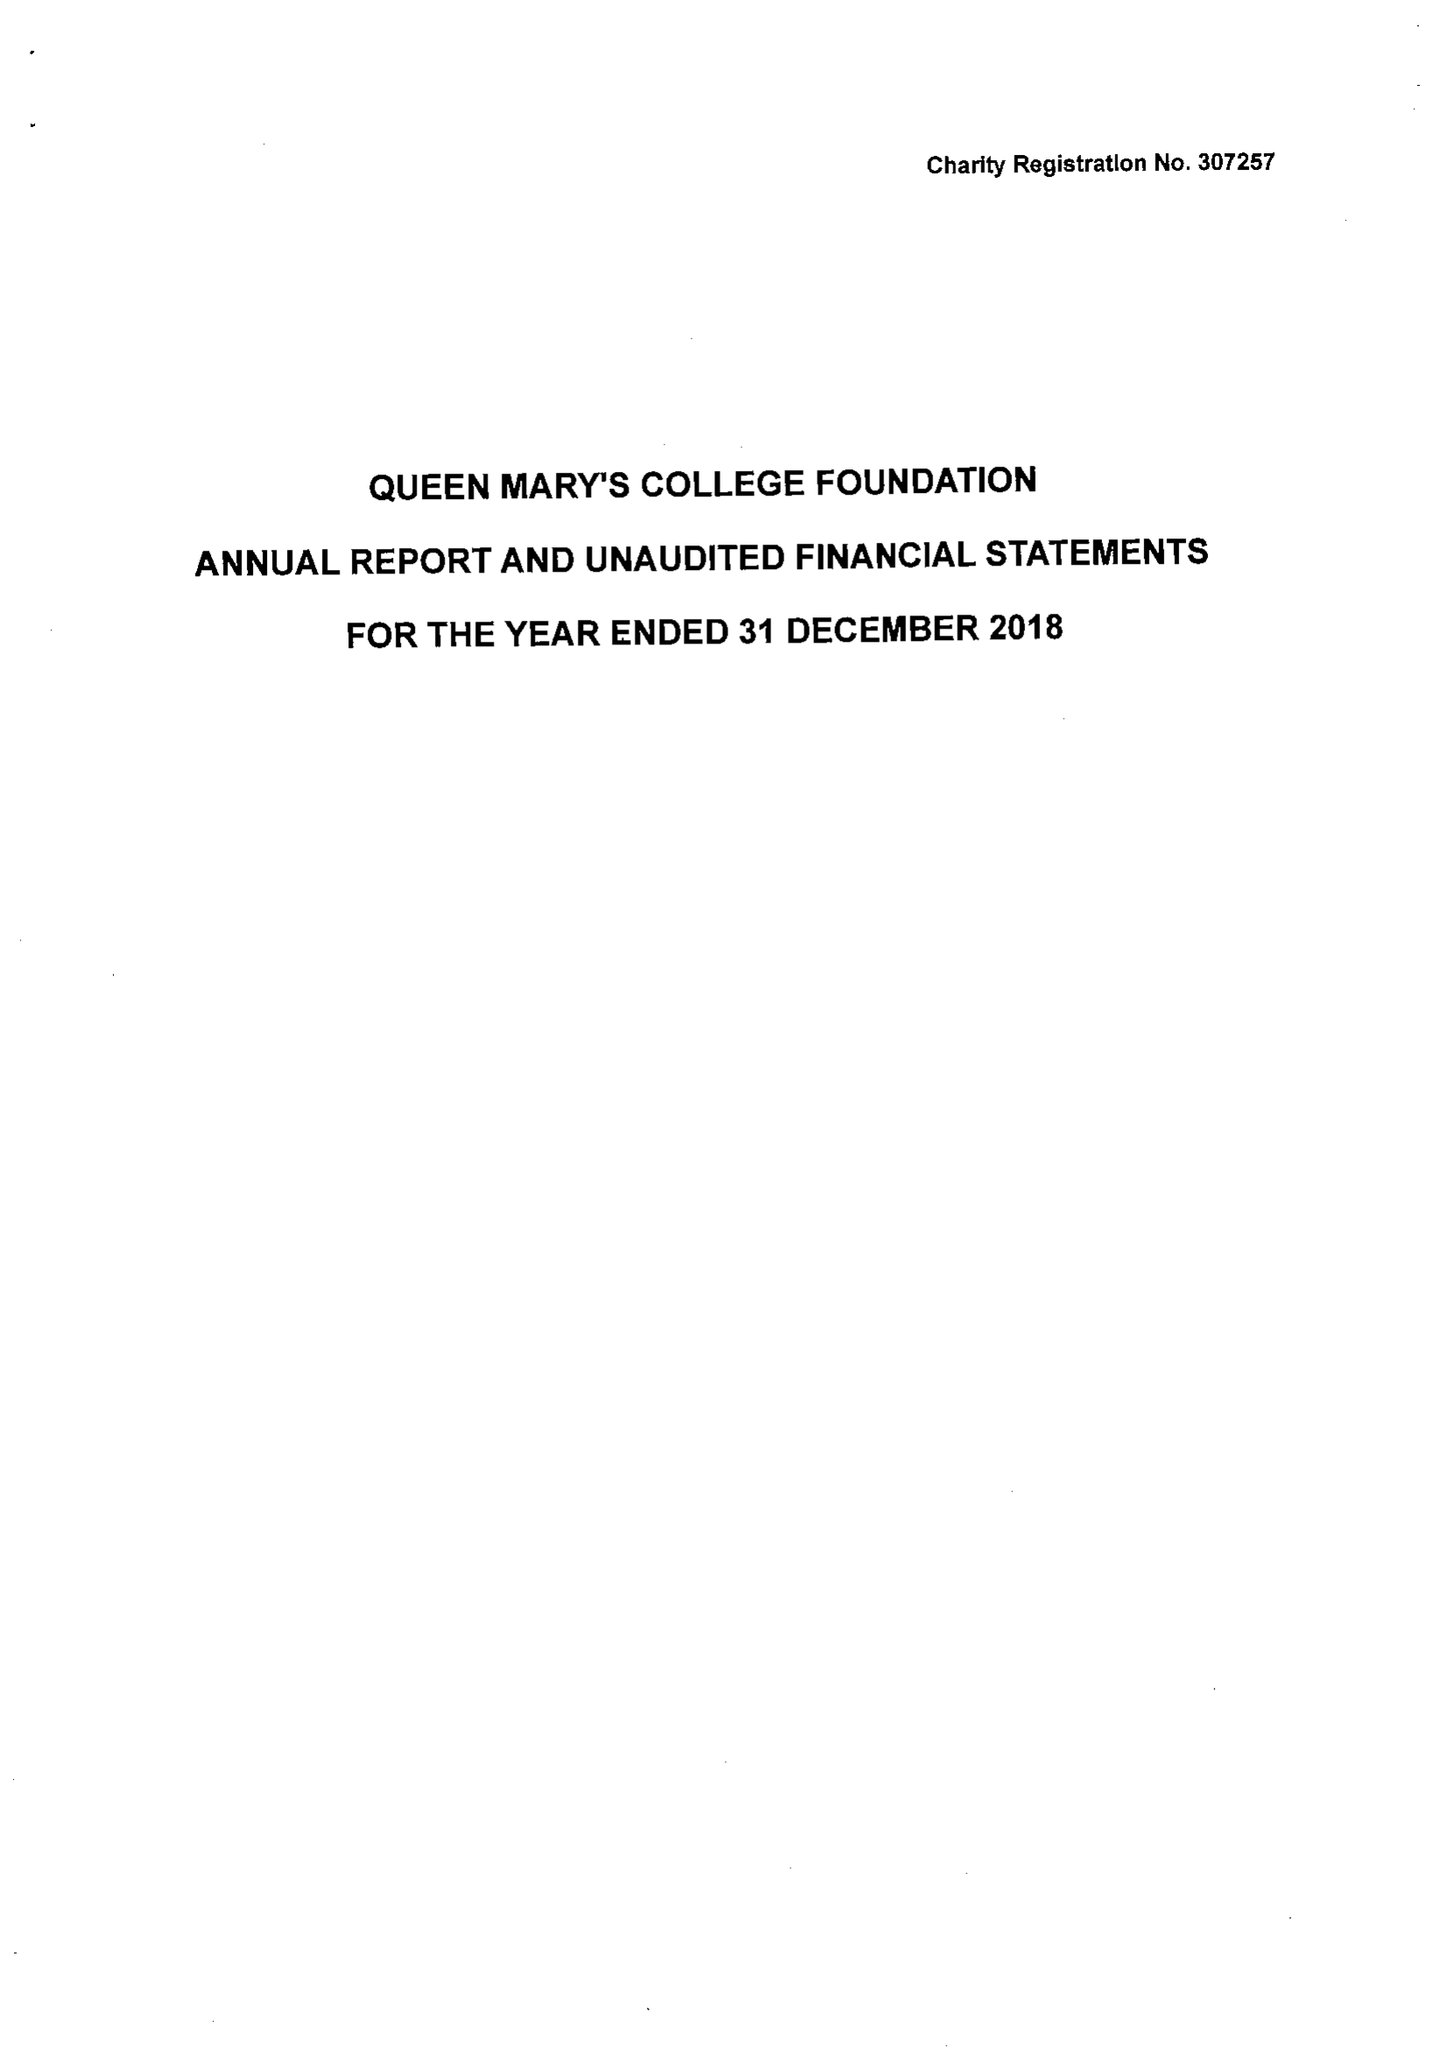What is the value for the charity_number?
Answer the question using a single word or phrase. 307257 